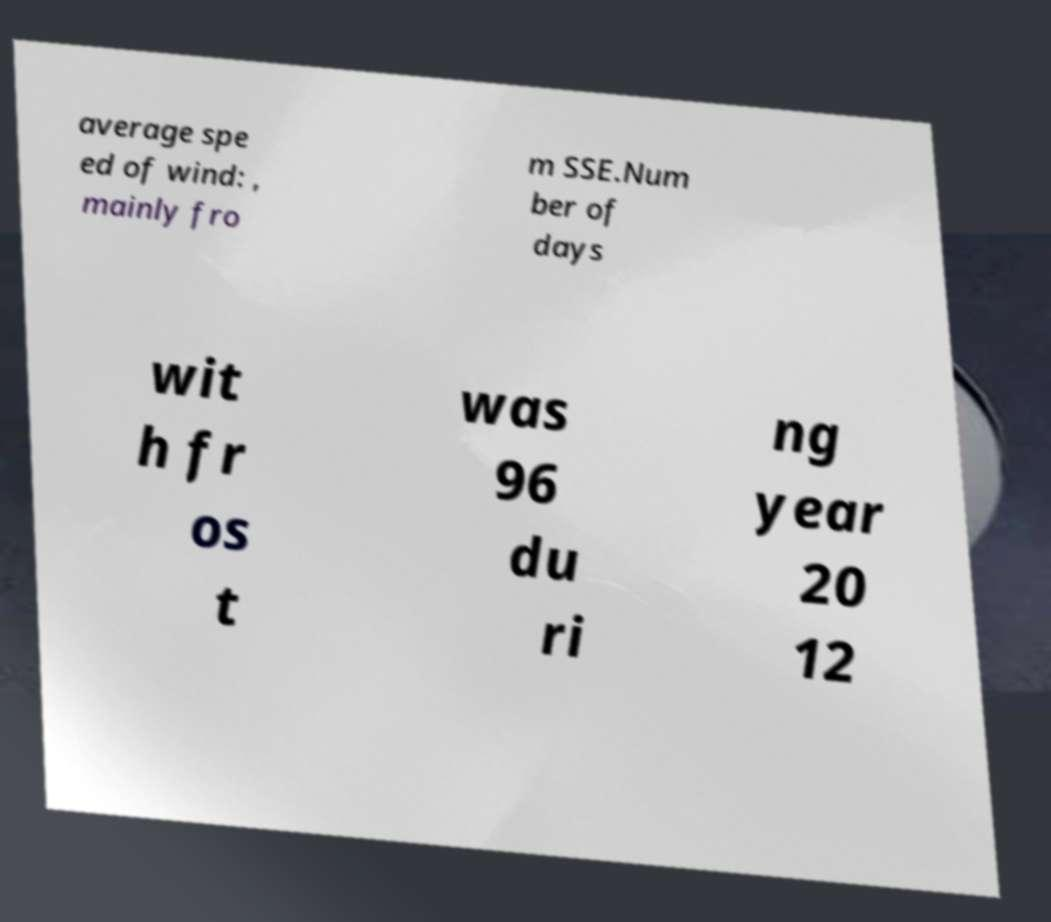Please identify and transcribe the text found in this image. average spe ed of wind: , mainly fro m SSE.Num ber of days wit h fr os t was 96 du ri ng year 20 12 